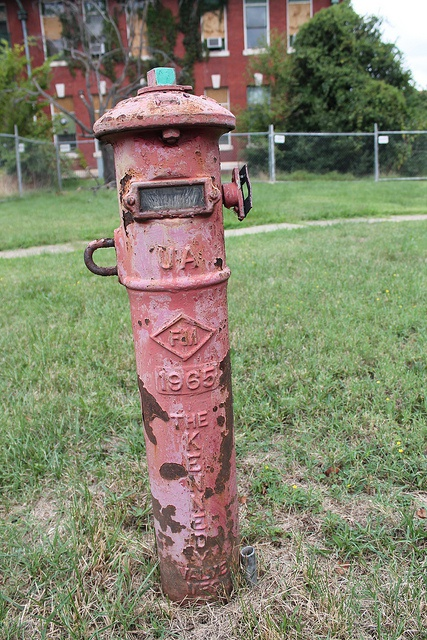Describe the objects in this image and their specific colors. I can see a fire hydrant in black, brown, lightpink, gray, and darkgray tones in this image. 